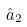Convert formula to latex. <formula><loc_0><loc_0><loc_500><loc_500>\hat { a } _ { 2 }</formula> 